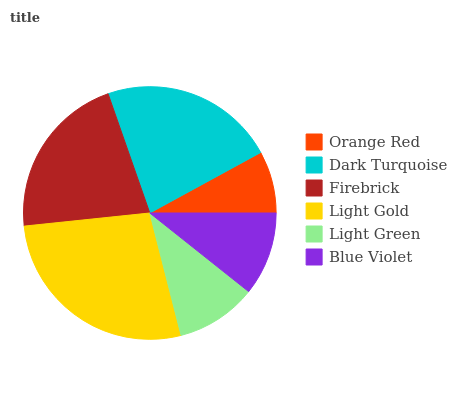Is Orange Red the minimum?
Answer yes or no. Yes. Is Light Gold the maximum?
Answer yes or no. Yes. Is Dark Turquoise the minimum?
Answer yes or no. No. Is Dark Turquoise the maximum?
Answer yes or no. No. Is Dark Turquoise greater than Orange Red?
Answer yes or no. Yes. Is Orange Red less than Dark Turquoise?
Answer yes or no. Yes. Is Orange Red greater than Dark Turquoise?
Answer yes or no. No. Is Dark Turquoise less than Orange Red?
Answer yes or no. No. Is Firebrick the high median?
Answer yes or no. Yes. Is Blue Violet the low median?
Answer yes or no. Yes. Is Dark Turquoise the high median?
Answer yes or no. No. Is Light Green the low median?
Answer yes or no. No. 